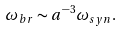<formula> <loc_0><loc_0><loc_500><loc_500>\omega _ { b r } \sim a ^ { - 3 } \omega _ { s y n } .</formula> 